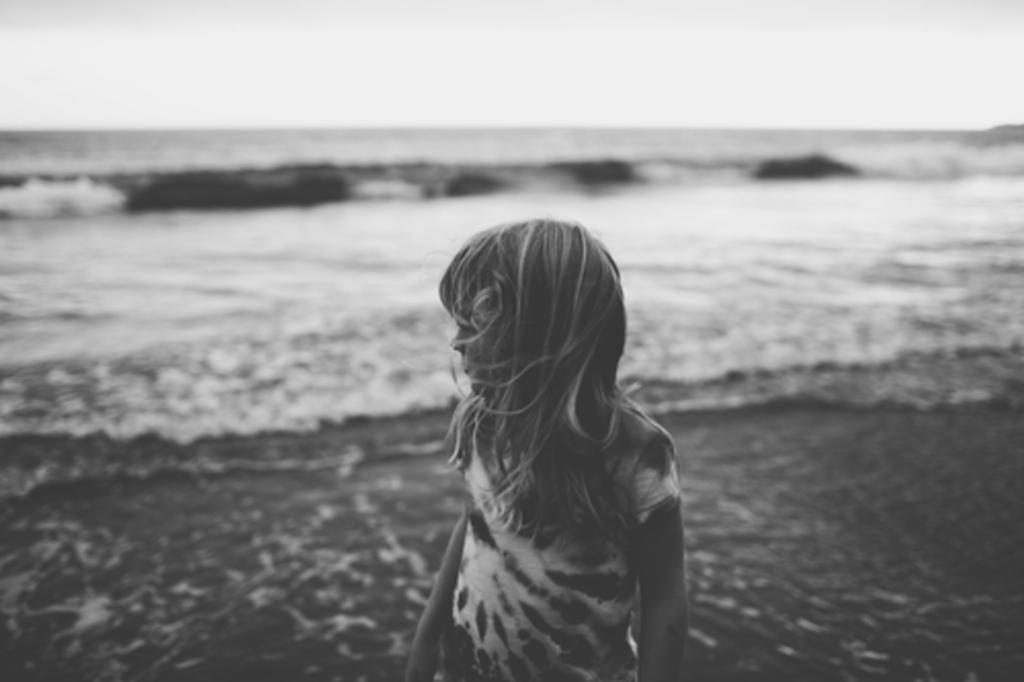What is the main subject of the image? There is a person standing in the image. What can be seen in the background of the image? There is water visible in the background of the image. How is the image presented in terms of color? The image is in black and white. What title is given to the person standing in the image? There is no title given to the person standing in the image, as it is not mentioned in the provided facts. 